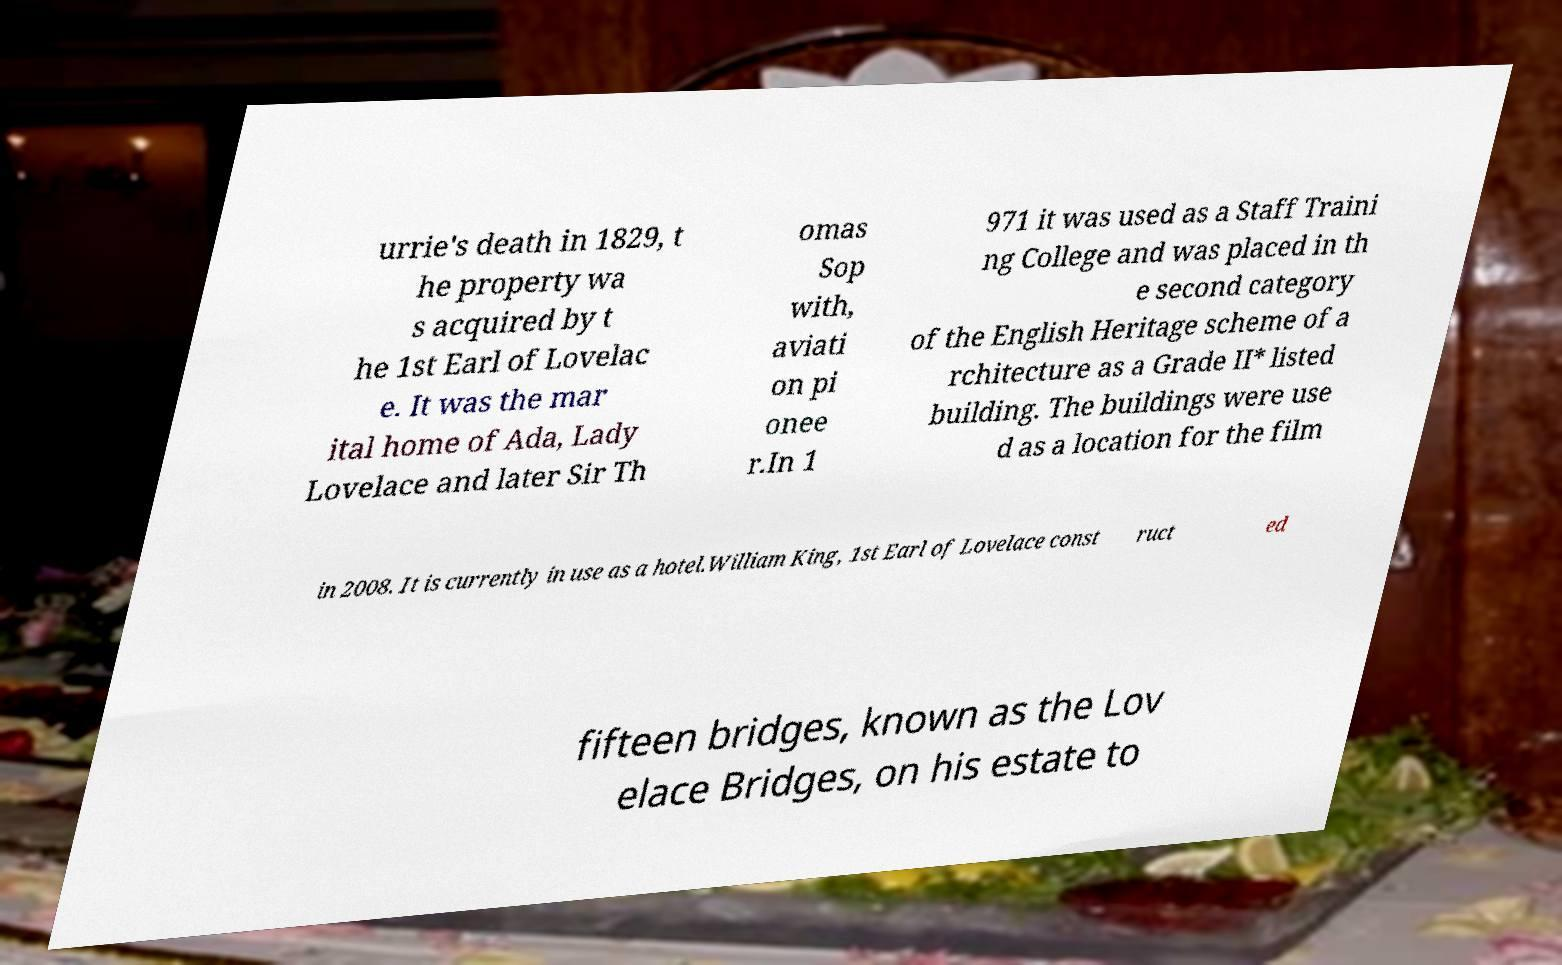There's text embedded in this image that I need extracted. Can you transcribe it verbatim? urrie's death in 1829, t he property wa s acquired by t he 1st Earl of Lovelac e. It was the mar ital home of Ada, Lady Lovelace and later Sir Th omas Sop with, aviati on pi onee r.In 1 971 it was used as a Staff Traini ng College and was placed in th e second category of the English Heritage scheme of a rchitecture as a Grade II* listed building. The buildings were use d as a location for the film in 2008. It is currently in use as a hotel.William King, 1st Earl of Lovelace const ruct ed fifteen bridges, known as the Lov elace Bridges, on his estate to 